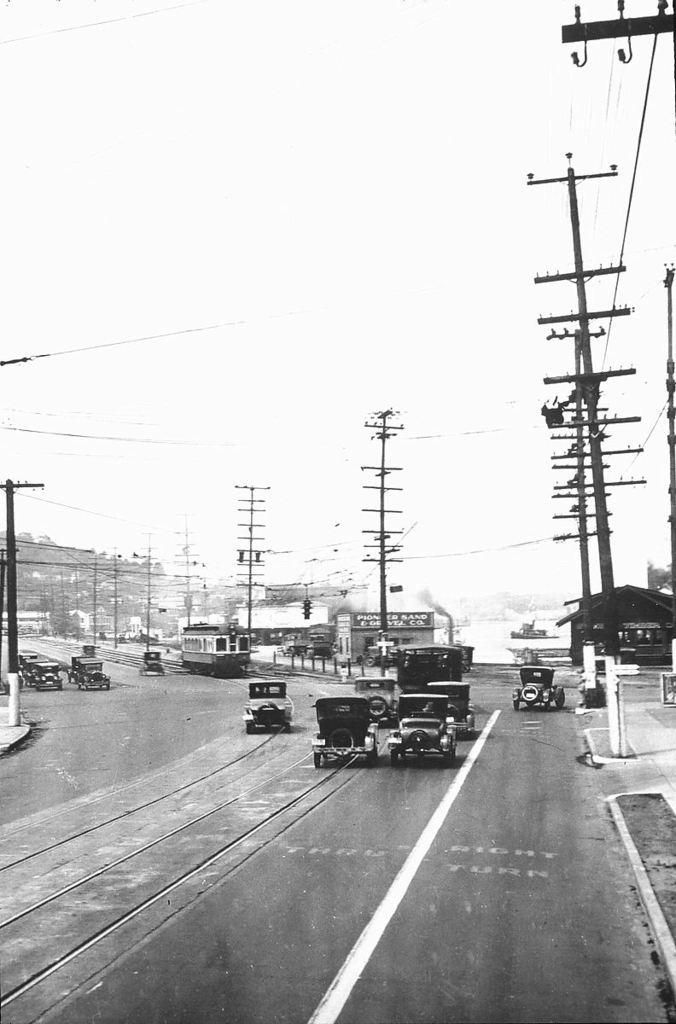What is happening on the road in the image? There are vehicles moving on the road in the image. What structures can be seen alongside the road? There are electric poles in the image. What is connected to the electric poles? Wires are connected to the electric poles. What is the condition of the sky in the image? The sky is clear in the image. What verse can be heard being recited by the electric poles in the image? There is no verse being recited by the electric poles in the image, as they are inanimate objects. What is the size of the pull that is attached to the electric poles in the image? There is no pull attached to the electric poles in the image; only wires are connected to them. 